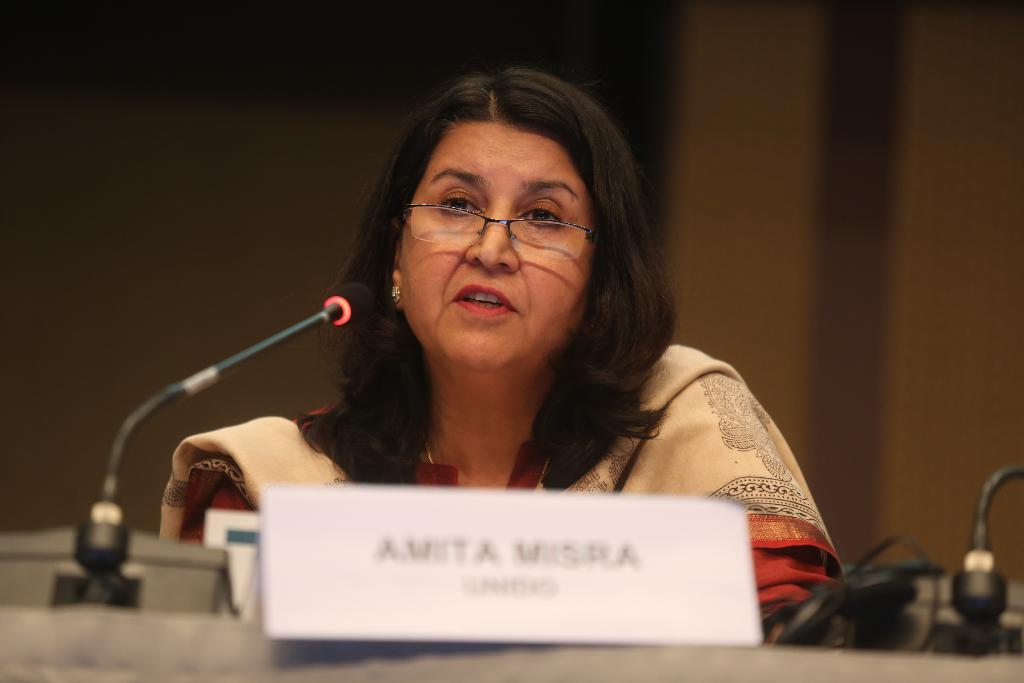What is the woman in the image doing? The woman is sitting in the image. What can be seen on the woman's face? The woman is wearing spectacles. What is in front of the woman? There is a name board and a microphone in front of the woman. What is on the table in front of the woman? There are objects on the table in front of the woman. Can you describe the background of the image? The background of the image is blurred. What type of glove is the woman wearing in the image? There is no glove visible on the woman in the image. How does the woman contribute to the harmony of the group in the image? There is no group or indication of harmony in the image; it only features a woman sitting with a name board and microphone in front of her. 